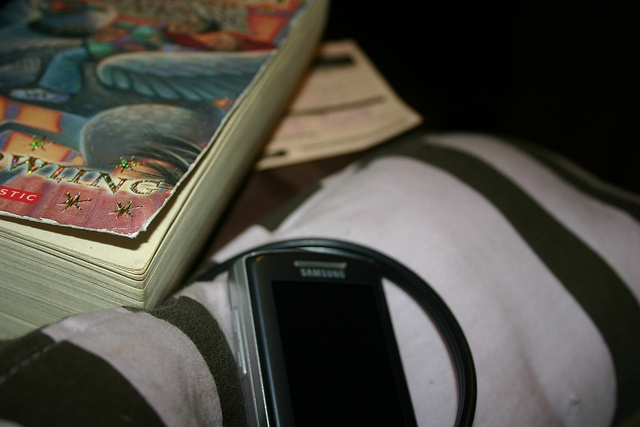Describe the objects in this image and their specific colors. I can see book in black and gray tones and cell phone in black, gray, darkgray, and purple tones in this image. 